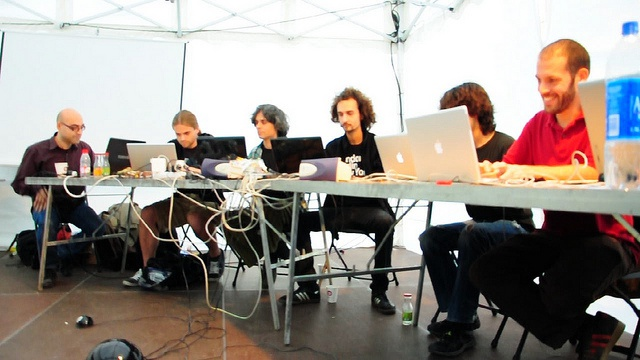Describe the objects in this image and their specific colors. I can see people in white, black, red, orange, and brown tones, people in white, black, darkgray, ivory, and gray tones, people in white, black, maroon, gray, and darkgray tones, people in white, black, darkgray, gray, and ivory tones, and people in white, black, maroon, brown, and tan tones in this image. 